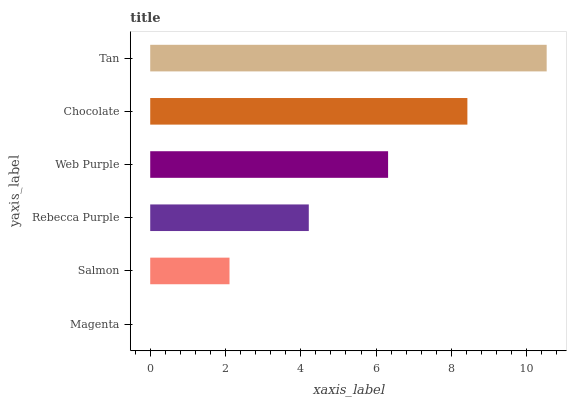Is Magenta the minimum?
Answer yes or no. Yes. Is Tan the maximum?
Answer yes or no. Yes. Is Salmon the minimum?
Answer yes or no. No. Is Salmon the maximum?
Answer yes or no. No. Is Salmon greater than Magenta?
Answer yes or no. Yes. Is Magenta less than Salmon?
Answer yes or no. Yes. Is Magenta greater than Salmon?
Answer yes or no. No. Is Salmon less than Magenta?
Answer yes or no. No. Is Web Purple the high median?
Answer yes or no. Yes. Is Rebecca Purple the low median?
Answer yes or no. Yes. Is Salmon the high median?
Answer yes or no. No. Is Tan the low median?
Answer yes or no. No. 